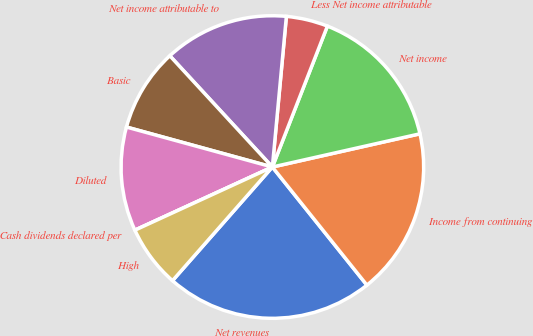Convert chart. <chart><loc_0><loc_0><loc_500><loc_500><pie_chart><fcel>Net revenues<fcel>Income from continuing<fcel>Net income<fcel>Less Net income attributable<fcel>Net income attributable to<fcel>Basic<fcel>Diluted<fcel>Cash dividends declared per<fcel>High<nl><fcel>22.22%<fcel>17.78%<fcel>15.55%<fcel>4.45%<fcel>13.33%<fcel>8.89%<fcel>11.11%<fcel>0.0%<fcel>6.67%<nl></chart> 